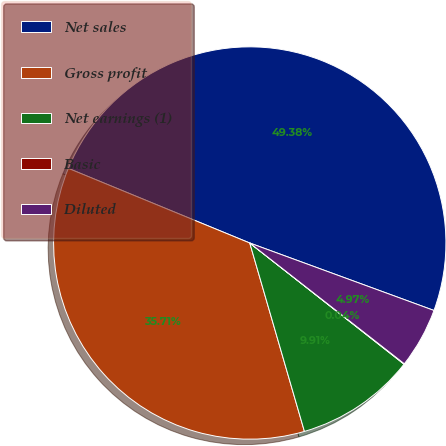Convert chart. <chart><loc_0><loc_0><loc_500><loc_500><pie_chart><fcel>Net sales<fcel>Gross profit<fcel>Net earnings (1)<fcel>Basic<fcel>Diluted<nl><fcel>49.38%<fcel>35.71%<fcel>9.91%<fcel>0.04%<fcel>4.97%<nl></chart> 